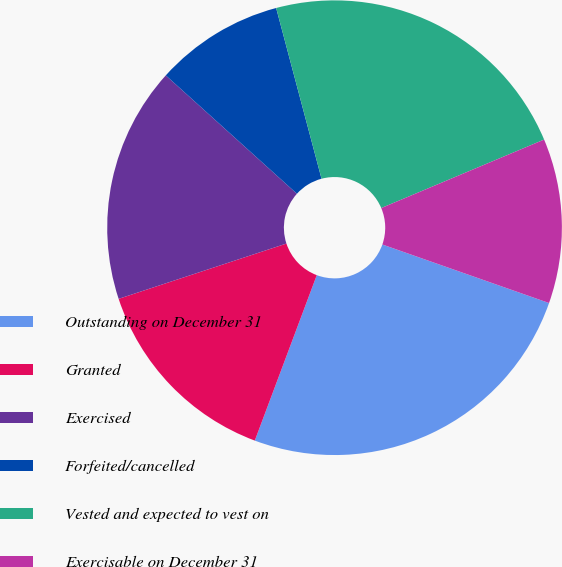<chart> <loc_0><loc_0><loc_500><loc_500><pie_chart><fcel>Outstanding on December 31<fcel>Granted<fcel>Exercised<fcel>Forfeited/cancelled<fcel>Vested and expected to vest on<fcel>Exercisable on December 31<nl><fcel>25.33%<fcel>14.23%<fcel>16.75%<fcel>9.18%<fcel>22.8%<fcel>11.71%<nl></chart> 